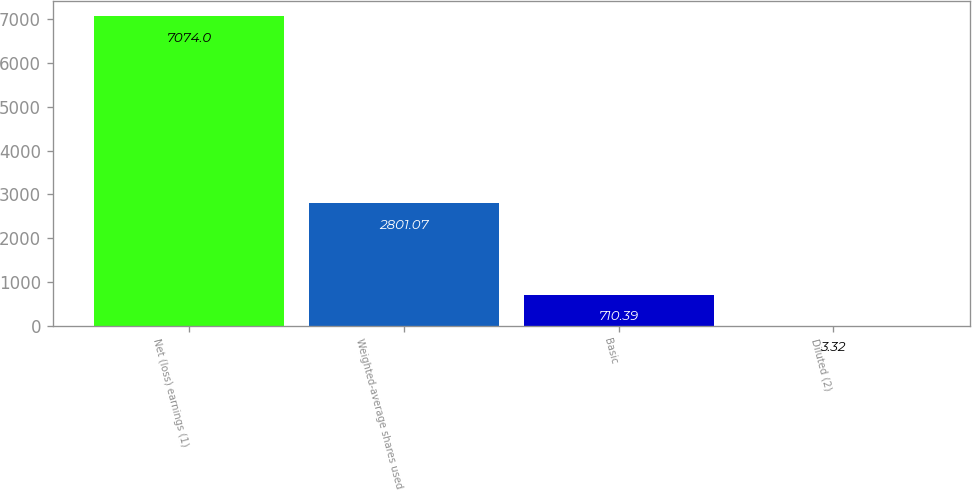Convert chart to OTSL. <chart><loc_0><loc_0><loc_500><loc_500><bar_chart><fcel>Net (loss) earnings (1)<fcel>Weighted-average shares used<fcel>Basic<fcel>Diluted (2)<nl><fcel>7074<fcel>2801.07<fcel>710.39<fcel>3.32<nl></chart> 